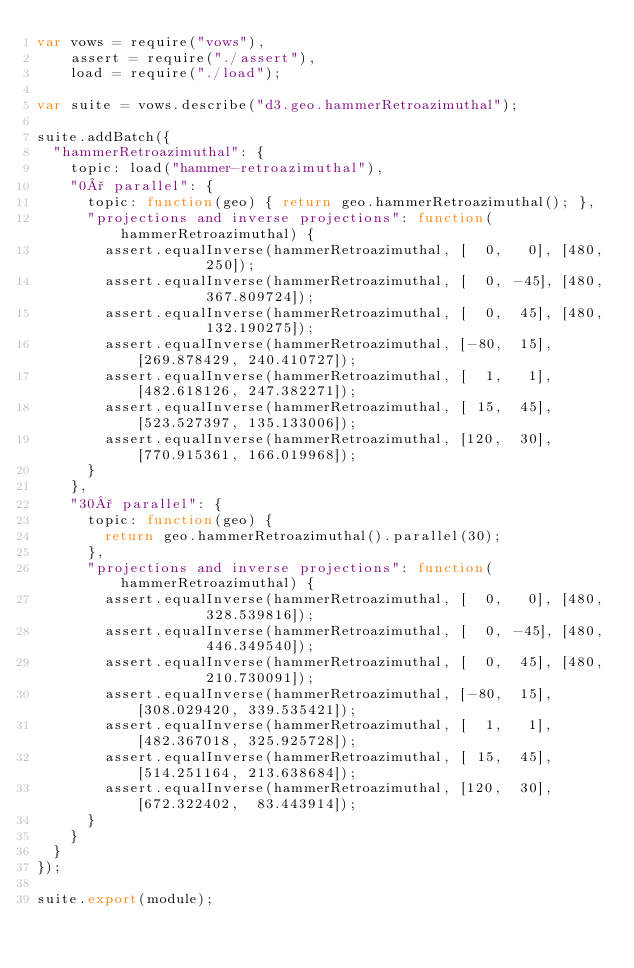<code> <loc_0><loc_0><loc_500><loc_500><_JavaScript_>var vows = require("vows"),
    assert = require("./assert"),
    load = require("./load");

var suite = vows.describe("d3.geo.hammerRetroazimuthal");

suite.addBatch({
  "hammerRetroazimuthal": {
    topic: load("hammer-retroazimuthal"),
    "0° parallel": {
      topic: function(geo) { return geo.hammerRetroazimuthal(); },
      "projections and inverse projections": function(hammerRetroazimuthal) {
        assert.equalInverse(hammerRetroazimuthal, [  0,   0], [480,        250]);
        assert.equalInverse(hammerRetroazimuthal, [  0, -45], [480,        367.809724]);
        assert.equalInverse(hammerRetroazimuthal, [  0,  45], [480,        132.190275]);
        assert.equalInverse(hammerRetroazimuthal, [-80,  15], [269.878429, 240.410727]);
        assert.equalInverse(hammerRetroazimuthal, [  1,   1], [482.618126, 247.382271]);
        assert.equalInverse(hammerRetroazimuthal, [ 15,  45], [523.527397, 135.133006]);
        assert.equalInverse(hammerRetroazimuthal, [120,  30], [770.915361, 166.019968]);
      }
    },
    "30° parallel": {
      topic: function(geo) {
        return geo.hammerRetroazimuthal().parallel(30);
      },
      "projections and inverse projections": function(hammerRetroazimuthal) {
        assert.equalInverse(hammerRetroazimuthal, [  0,   0], [480,        328.539816]);
        assert.equalInverse(hammerRetroazimuthal, [  0, -45], [480,        446.349540]);
        assert.equalInverse(hammerRetroazimuthal, [  0,  45], [480,        210.730091]);
        assert.equalInverse(hammerRetroazimuthal, [-80,  15], [308.029420, 339.535421]);
        assert.equalInverse(hammerRetroazimuthal, [  1,   1], [482.367018, 325.925728]);
        assert.equalInverse(hammerRetroazimuthal, [ 15,  45], [514.251164, 213.638684]);
        assert.equalInverse(hammerRetroazimuthal, [120,  30], [672.322402,  83.443914]);
      }
    }
  }
});

suite.export(module);
</code> 